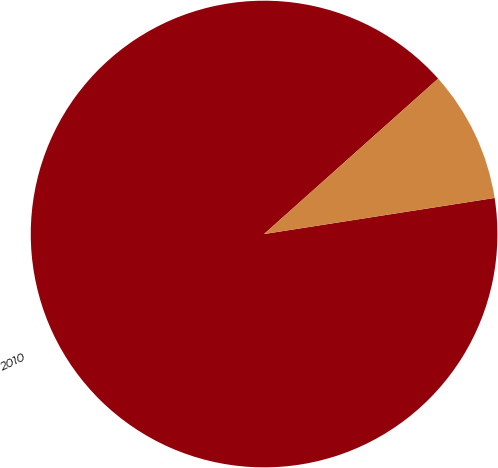<chart> <loc_0><loc_0><loc_500><loc_500><pie_chart><fcel>2010<fcel>Unnamed: 1<nl><fcel>90.87%<fcel>9.13%<nl></chart> 